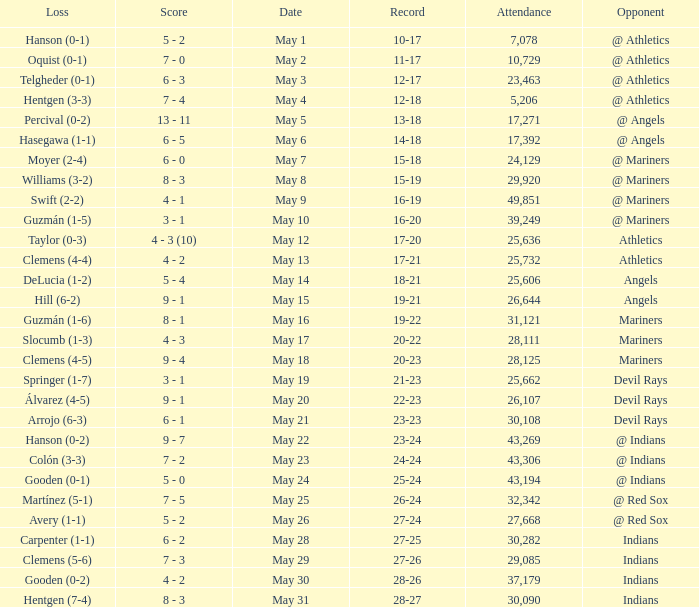When was the record 27-25? May 28. 